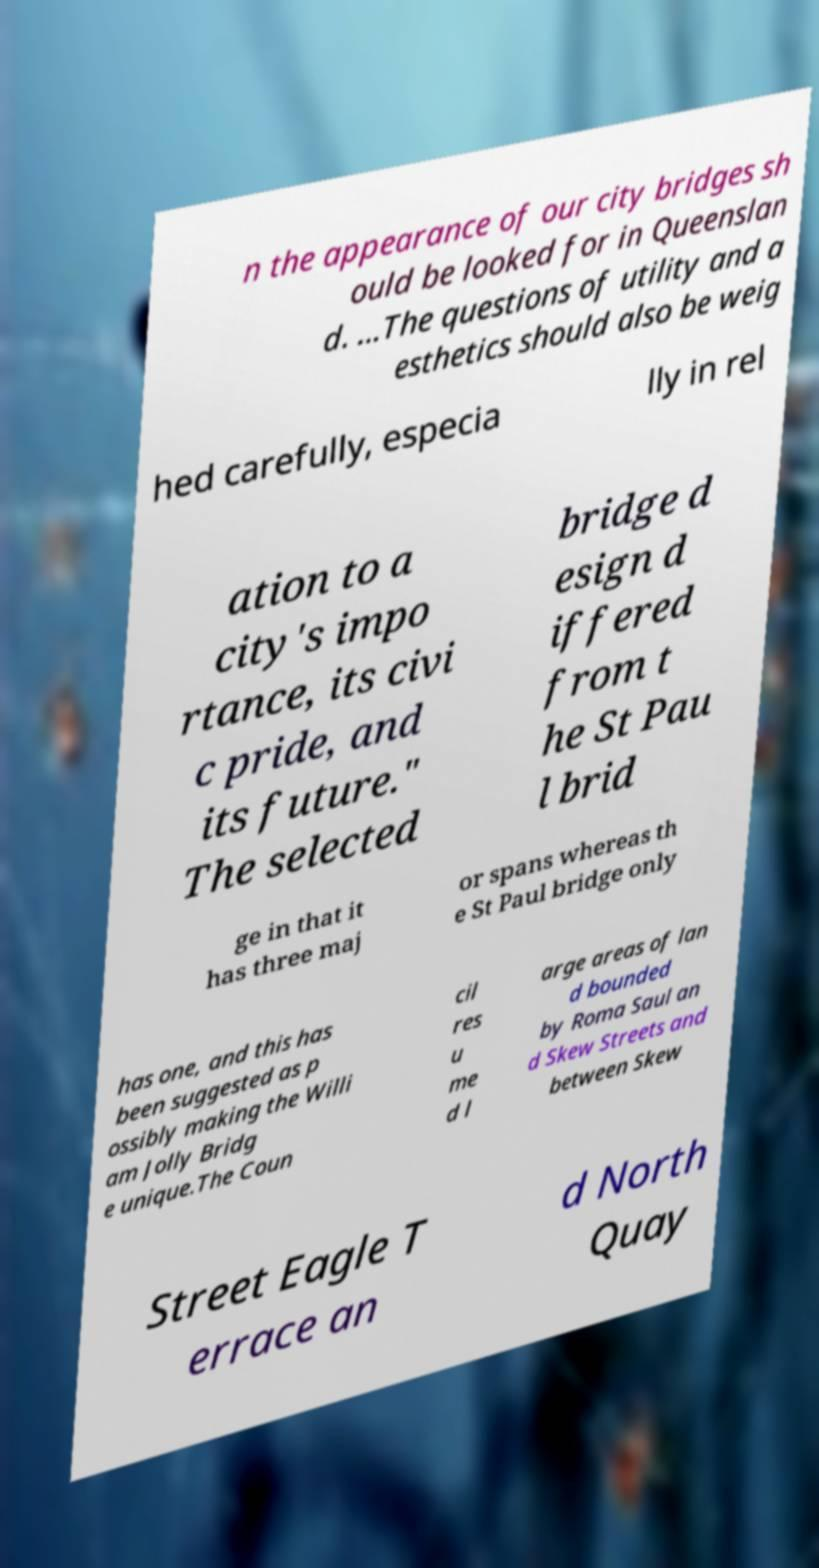There's text embedded in this image that I need extracted. Can you transcribe it verbatim? n the appearance of our city bridges sh ould be looked for in Queenslan d. ...The questions of utility and a esthetics should also be weig hed carefully, especia lly in rel ation to a city's impo rtance, its civi c pride, and its future." The selected bridge d esign d iffered from t he St Pau l brid ge in that it has three maj or spans whereas th e St Paul bridge only has one, and this has been suggested as p ossibly making the Willi am Jolly Bridg e unique.The Coun cil res u me d l arge areas of lan d bounded by Roma Saul an d Skew Streets and between Skew Street Eagle T errace an d North Quay 